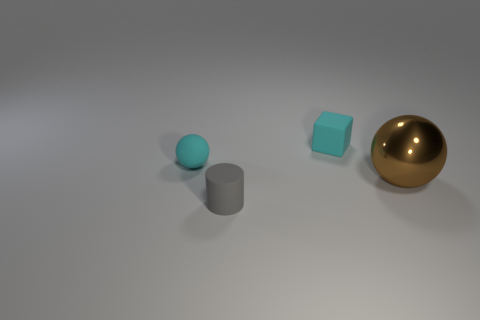Can you describe the objects and their arrangement? Certainly! The image shows four objects on a flat surface, all varying in shape. From left to right, there is a small sphere with a matte teal surface, a taller cylinder with a matte gray surface, a cube with a slightly translucent teal surface, and a large sphere with a glossy gold surface. They are placed in a horizontal line with even spacing between them, which creates a visually balanced composition. 